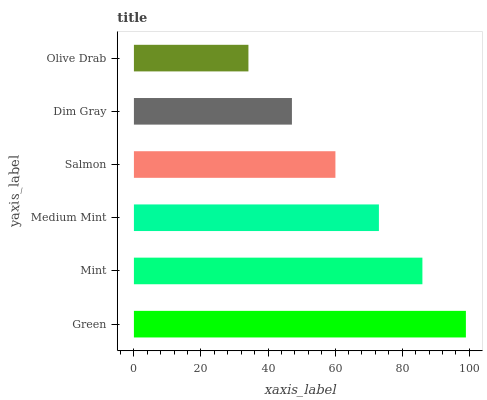Is Olive Drab the minimum?
Answer yes or no. Yes. Is Green the maximum?
Answer yes or no. Yes. Is Mint the minimum?
Answer yes or no. No. Is Mint the maximum?
Answer yes or no. No. Is Green greater than Mint?
Answer yes or no. Yes. Is Mint less than Green?
Answer yes or no. Yes. Is Mint greater than Green?
Answer yes or no. No. Is Green less than Mint?
Answer yes or no. No. Is Medium Mint the high median?
Answer yes or no. Yes. Is Salmon the low median?
Answer yes or no. Yes. Is Dim Gray the high median?
Answer yes or no. No. Is Dim Gray the low median?
Answer yes or no. No. 